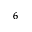Convert formula to latex. <formula><loc_0><loc_0><loc_500><loc_500>^ { 6 }</formula> 